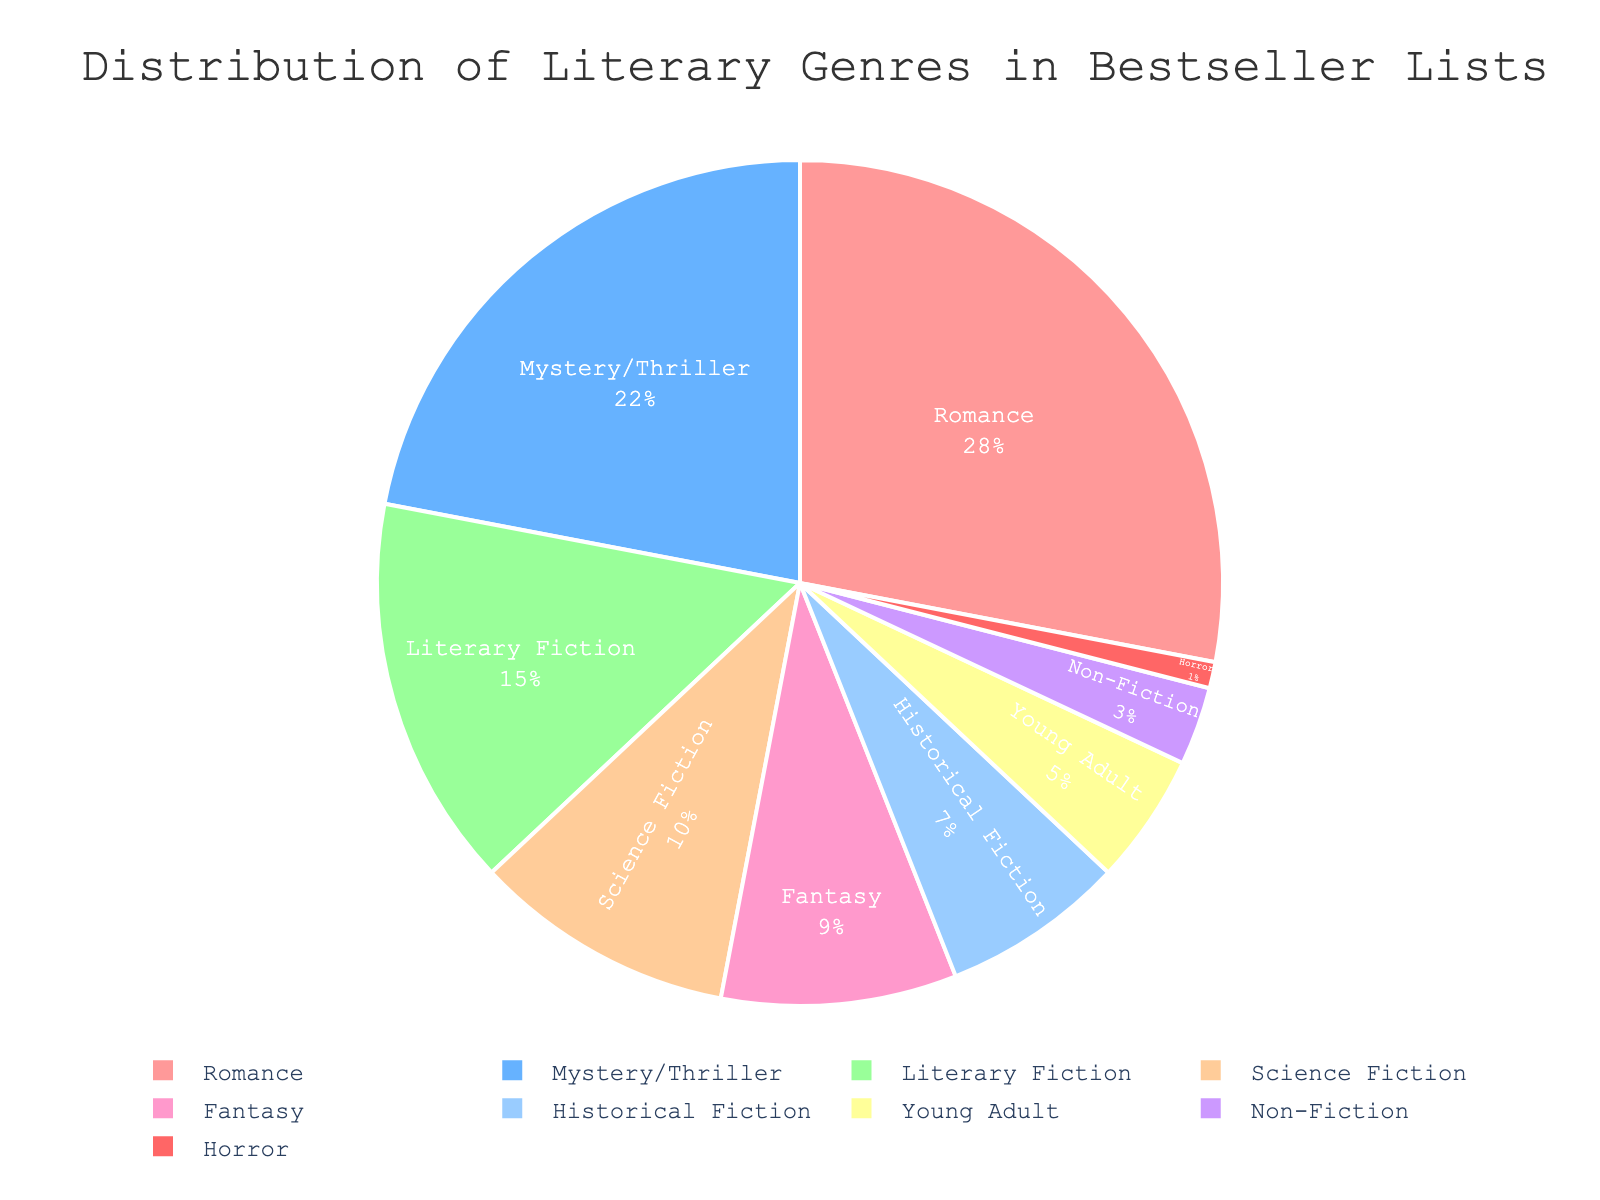Which genre occupies the largest portion of the pie chart? Look for the genre with the largest slice in the pie chart. The Romance section appears to be the biggest.
Answer: Romance Which genre has a smaller percentage, Science Fiction or Fantasy? Identify the sections labeled "Science Fiction" and "Fantasy" and compare their sizes. Science Fiction is 10%, while Fantasy is 9%.
Answer: Fantasy What is the total percentage for genres that make up less than 10% each? Add the percentages of Science Fiction (10%), Fantasy (9%), Historical Fiction (7%), Young Adult (5%), Non-Fiction (3%), and Horror (1%). Thus, 10% + 9% + 7% + 5% + 3% + 1% = 35%.
Answer: 35% How much larger is the Romance genre compared to the Horror genre? Subtract the percentage of Horror (1%) from the percentage of Romance (28%). Therefore, 28% - 1% = 27%.
Answer: 27% Are the combined percentages of Literary Fiction and Mystery/Thriller greater than that of Romance? Add the percentages of Literary Fiction (15%) and Mystery/Thriller (22%) to get 15% + 22% = 37%. Compare with Romance which is 28%.
Answer: Yes Which genre, among those shown, is least common on bestseller lists? Find the genre with the smallest percentage in the chart. Horror has the smallest portion at 1%.
Answer: Horror Do Mystery/Thriller and Literary Fiction together constitute more than a quarter of the pie chart? Add up the percentages for Mystery/Thriller (22%) and Literary Fiction (15%) to get 22% + 15% = 37%. A quarter of the pie chart is 25%, so 37% is greater than 25%.
Answer: Yes If you combine the percentages of Non-Fiction and Horror, what fraction of the total do they account for? Add the percentages of Non-Fiction (3%) and Horror (1%). Thus, 3% + 1% = 4%. This is 4/100 or 1/25 of the total.
Answer: 1/25 How much smaller is Young Adult compared to Mystery/Thriller? Subtract the percentage of Young Adult (5%) from the percentage of Mystery/Thriller (22%). Thus, 22% - 5% = 17%.
Answer: 17% 